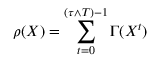<formula> <loc_0><loc_0><loc_500><loc_500>\rho ( X ) = \sum _ { t = 0 } ^ { ( \tau \wedge T ) - 1 } \Gamma ( X ^ { t } )</formula> 